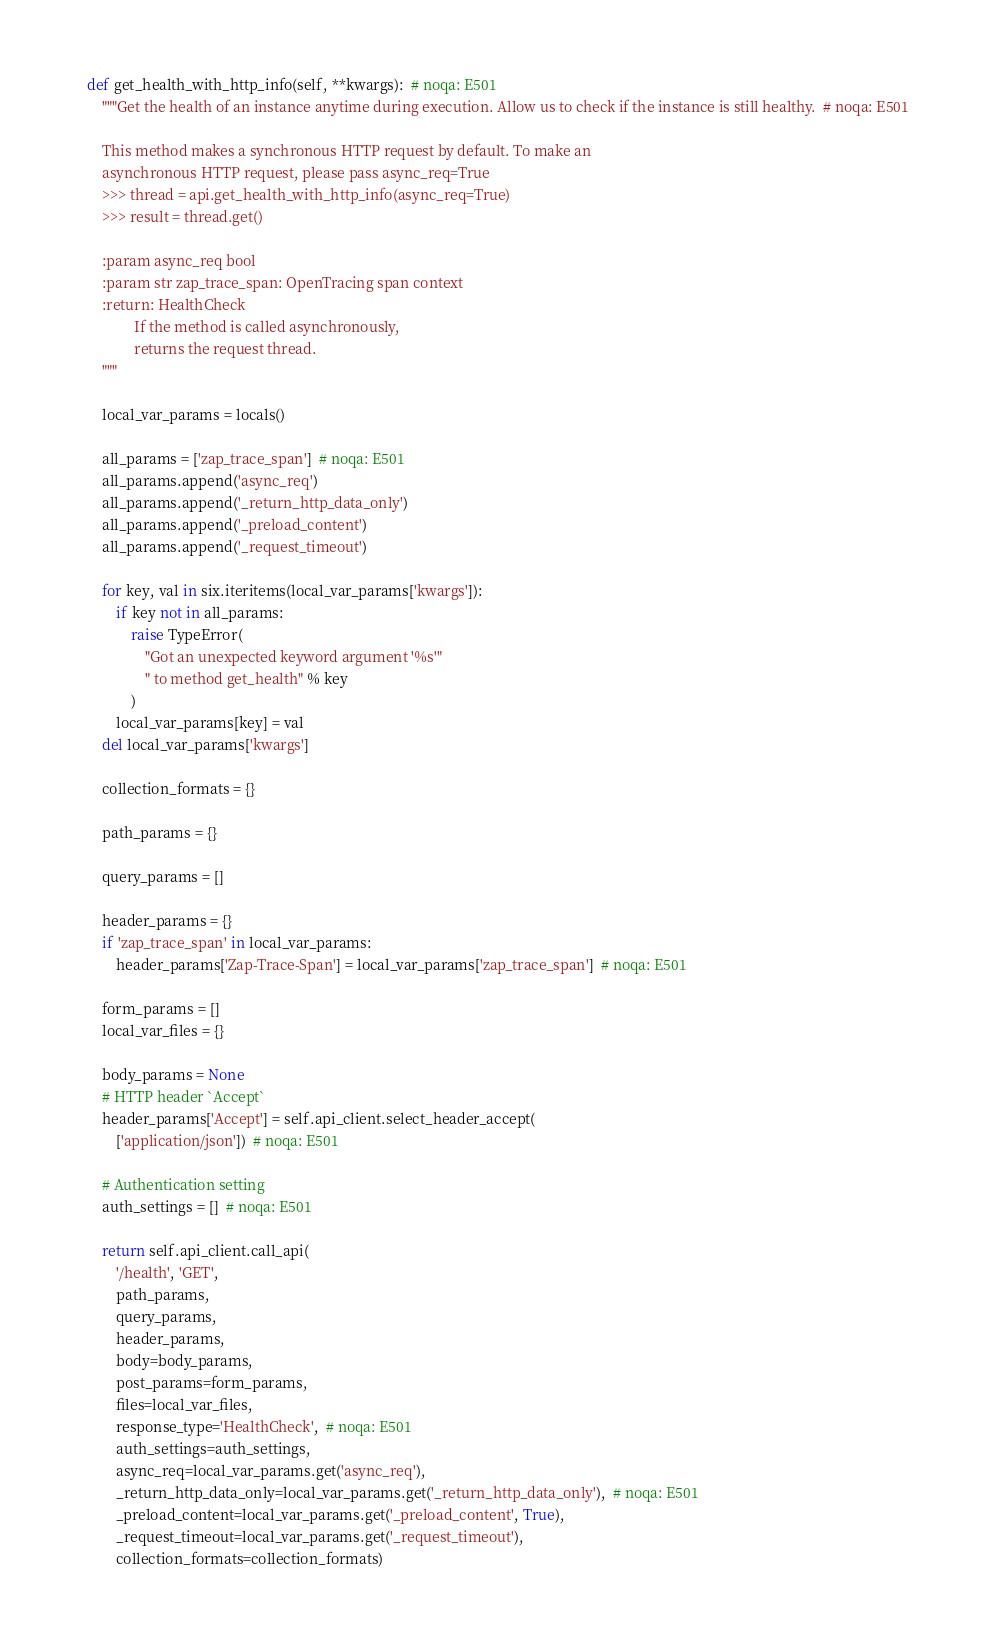<code> <loc_0><loc_0><loc_500><loc_500><_Python_>    def get_health_with_http_info(self, **kwargs):  # noqa: E501
        """Get the health of an instance anytime during execution. Allow us to check if the instance is still healthy.  # noqa: E501

        This method makes a synchronous HTTP request by default. To make an
        asynchronous HTTP request, please pass async_req=True
        >>> thread = api.get_health_with_http_info(async_req=True)
        >>> result = thread.get()

        :param async_req bool
        :param str zap_trace_span: OpenTracing span context
        :return: HealthCheck
                 If the method is called asynchronously,
                 returns the request thread.
        """

        local_var_params = locals()

        all_params = ['zap_trace_span']  # noqa: E501
        all_params.append('async_req')
        all_params.append('_return_http_data_only')
        all_params.append('_preload_content')
        all_params.append('_request_timeout')

        for key, val in six.iteritems(local_var_params['kwargs']):
            if key not in all_params:
                raise TypeError(
                    "Got an unexpected keyword argument '%s'"
                    " to method get_health" % key
                )
            local_var_params[key] = val
        del local_var_params['kwargs']

        collection_formats = {}

        path_params = {}

        query_params = []

        header_params = {}
        if 'zap_trace_span' in local_var_params:
            header_params['Zap-Trace-Span'] = local_var_params['zap_trace_span']  # noqa: E501

        form_params = []
        local_var_files = {}

        body_params = None
        # HTTP header `Accept`
        header_params['Accept'] = self.api_client.select_header_accept(
            ['application/json'])  # noqa: E501

        # Authentication setting
        auth_settings = []  # noqa: E501

        return self.api_client.call_api(
            '/health', 'GET',
            path_params,
            query_params,
            header_params,
            body=body_params,
            post_params=form_params,
            files=local_var_files,
            response_type='HealthCheck',  # noqa: E501
            auth_settings=auth_settings,
            async_req=local_var_params.get('async_req'),
            _return_http_data_only=local_var_params.get('_return_http_data_only'),  # noqa: E501
            _preload_content=local_var_params.get('_preload_content', True),
            _request_timeout=local_var_params.get('_request_timeout'),
            collection_formats=collection_formats)
</code> 